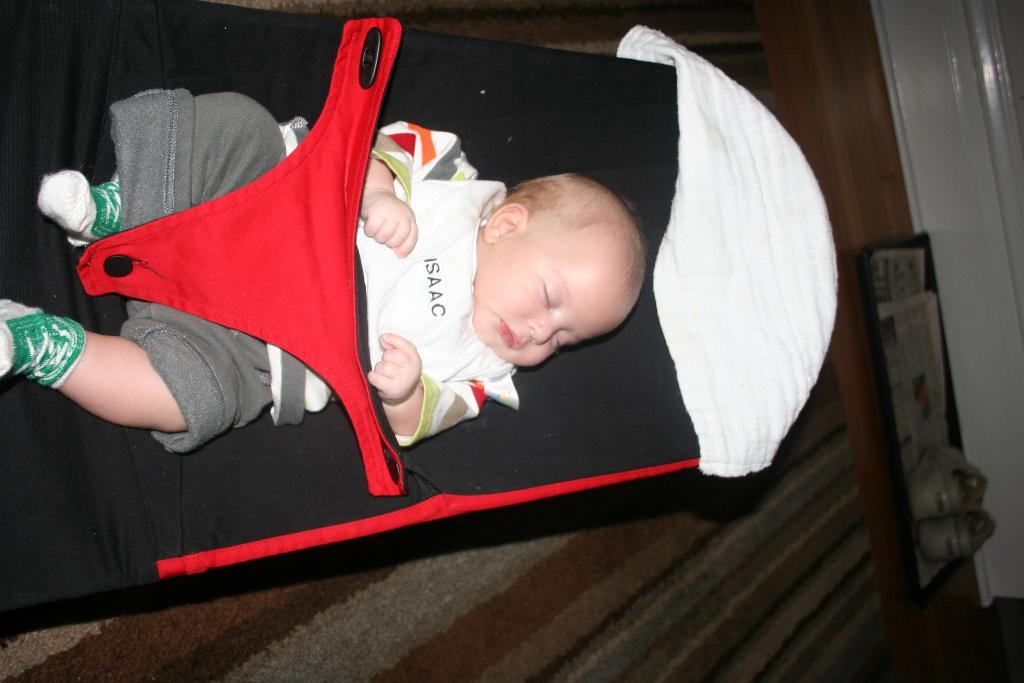What is the main subject of the image? There is a baby in the image. What is the baby wearing? The baby is wearing clothes and socks. What is the baby doing in the image? The baby is sleeping. What else can be seen in the image besides the baby? There are shoes visible in the image. What type of surface is the baby lying on? There is a floor in the image. How many cakes are being served at the amusement park in the image? There is no amusement park or cakes present in the image; it features a sleeping baby. Can you see an ant crawling on the baby's clothes in the image? There is no ant visible in the image. 